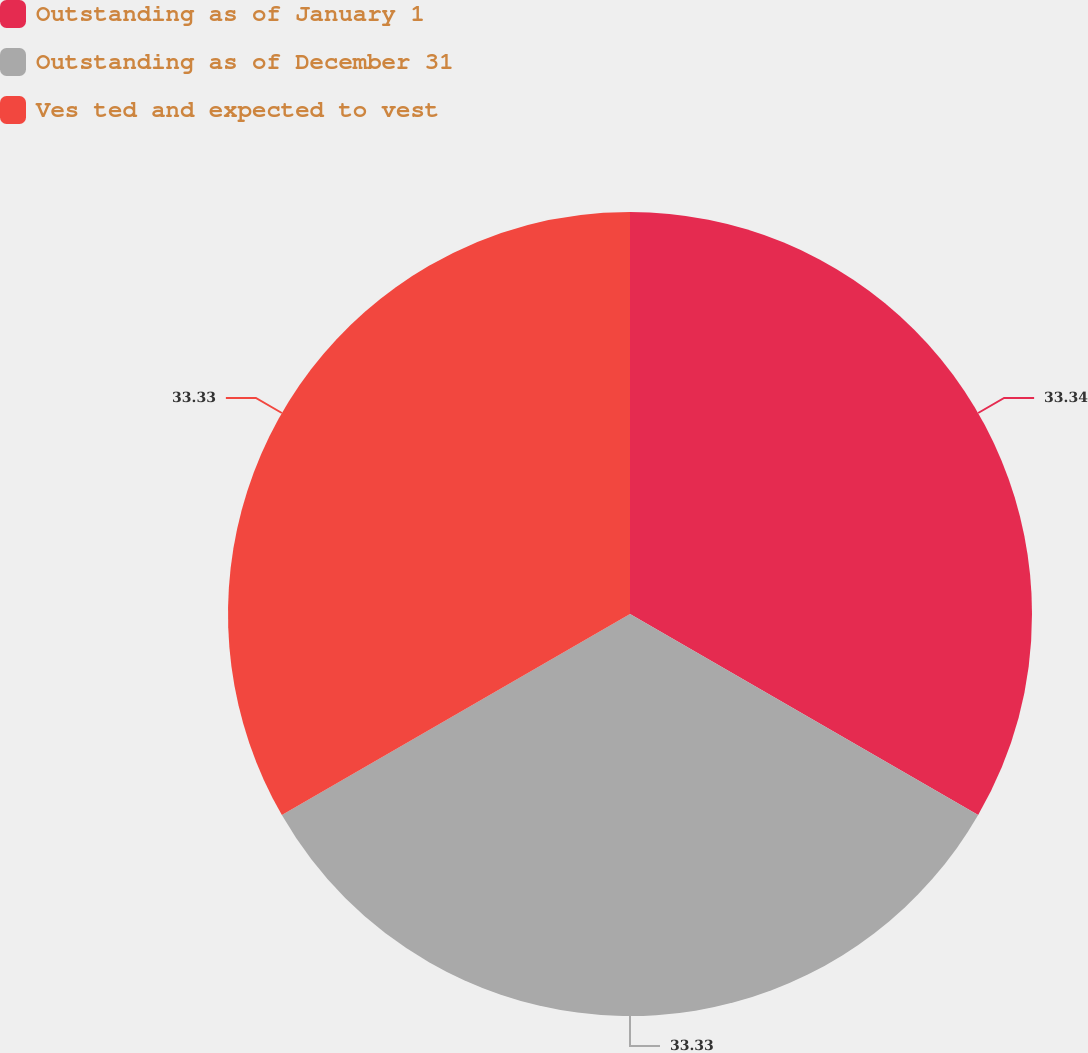Convert chart to OTSL. <chart><loc_0><loc_0><loc_500><loc_500><pie_chart><fcel>Outstanding as of January 1<fcel>Outstanding as of December 31<fcel>Ves ted and expected to vest<nl><fcel>33.33%<fcel>33.33%<fcel>33.33%<nl></chart> 